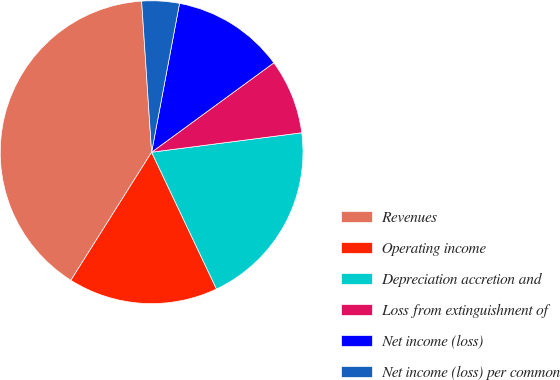Convert chart. <chart><loc_0><loc_0><loc_500><loc_500><pie_chart><fcel>Revenues<fcel>Operating income<fcel>Depreciation accretion and<fcel>Loss from extinguishment of<fcel>Net income (loss)<fcel>Net income (loss) per common<nl><fcel>40.0%<fcel>16.0%<fcel>20.0%<fcel>8.0%<fcel>12.0%<fcel>4.0%<nl></chart> 